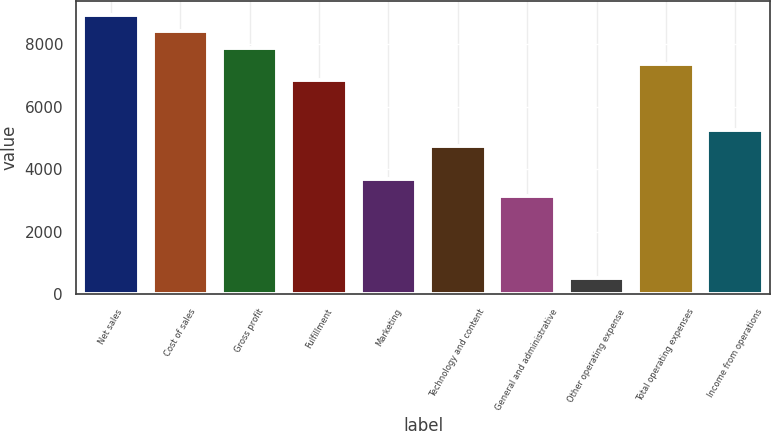Convert chart. <chart><loc_0><loc_0><loc_500><loc_500><bar_chart><fcel>Net sales<fcel>Cost of sales<fcel>Gross profit<fcel>Fulfillment<fcel>Marketing<fcel>Technology and content<fcel>General and administrative<fcel>Other operating expense<fcel>Total operating expenses<fcel>Income from operations<nl><fcel>8948.72<fcel>8422.33<fcel>7895.94<fcel>6843.16<fcel>3684.82<fcel>4737.6<fcel>3158.43<fcel>526.48<fcel>7369.55<fcel>5263.99<nl></chart> 